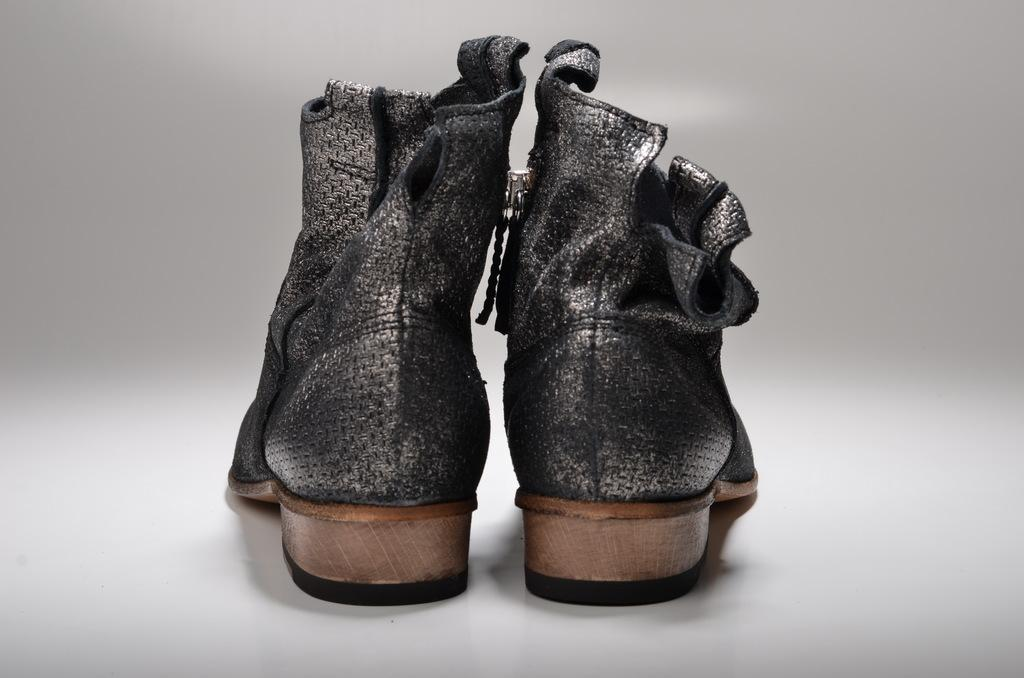What is located in the middle of the picture? There are shoes in the middle of the picture. What colors are the shoes? The shoes are in black and brown color. What is the color of the background in the image? The background of the image is white. What type of voyage are the shoes embarking on in the image? There is no indication of a voyage in the image; it simply shows shoes in black and brown color against a white background. 